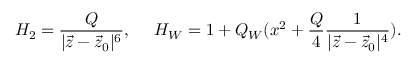<formula> <loc_0><loc_0><loc_500><loc_500>H _ { 2 } = { \frac { Q } { | \vec { z } - \vec { z } _ { 0 } | ^ { 6 } } } , \quad H _ { W } = 1 + Q _ { W } ( x ^ { 2 } + { \frac { Q } { 4 } } { \frac { 1 } { | \vec { z } - \vec { z } _ { 0 } | ^ { 4 } } } ) .</formula> 